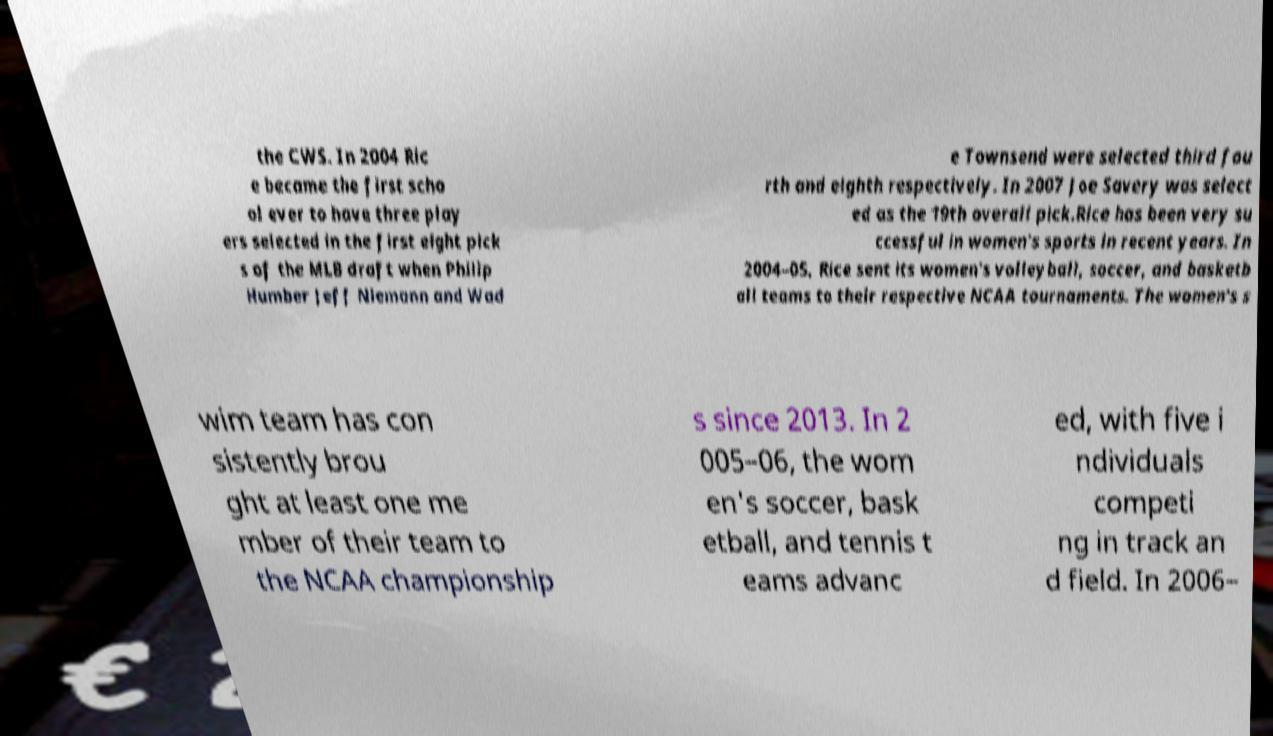I need the written content from this picture converted into text. Can you do that? the CWS. In 2004 Ric e became the first scho ol ever to have three play ers selected in the first eight pick s of the MLB draft when Philip Humber Jeff Niemann and Wad e Townsend were selected third fou rth and eighth respectively. In 2007 Joe Savery was select ed as the 19th overall pick.Rice has been very su ccessful in women's sports in recent years. In 2004–05, Rice sent its women's volleyball, soccer, and basketb all teams to their respective NCAA tournaments. The women's s wim team has con sistently brou ght at least one me mber of their team to the NCAA championship s since 2013. In 2 005–06, the wom en's soccer, bask etball, and tennis t eams advanc ed, with five i ndividuals competi ng in track an d field. In 2006– 